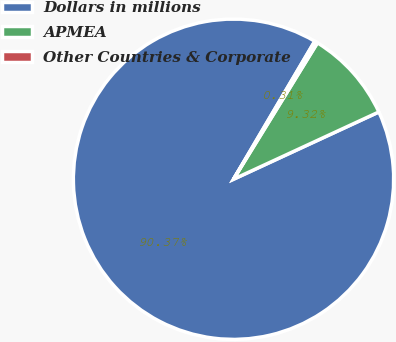Convert chart to OTSL. <chart><loc_0><loc_0><loc_500><loc_500><pie_chart><fcel>Dollars in millions<fcel>APMEA<fcel>Other Countries & Corporate<nl><fcel>90.37%<fcel>9.32%<fcel>0.31%<nl></chart> 